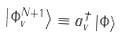<formula> <loc_0><loc_0><loc_500><loc_500>\left | \Phi _ { v } ^ { N + 1 } \right \rangle \equiv a _ { v } ^ { \dagger } \left | \Phi \right \rangle</formula> 